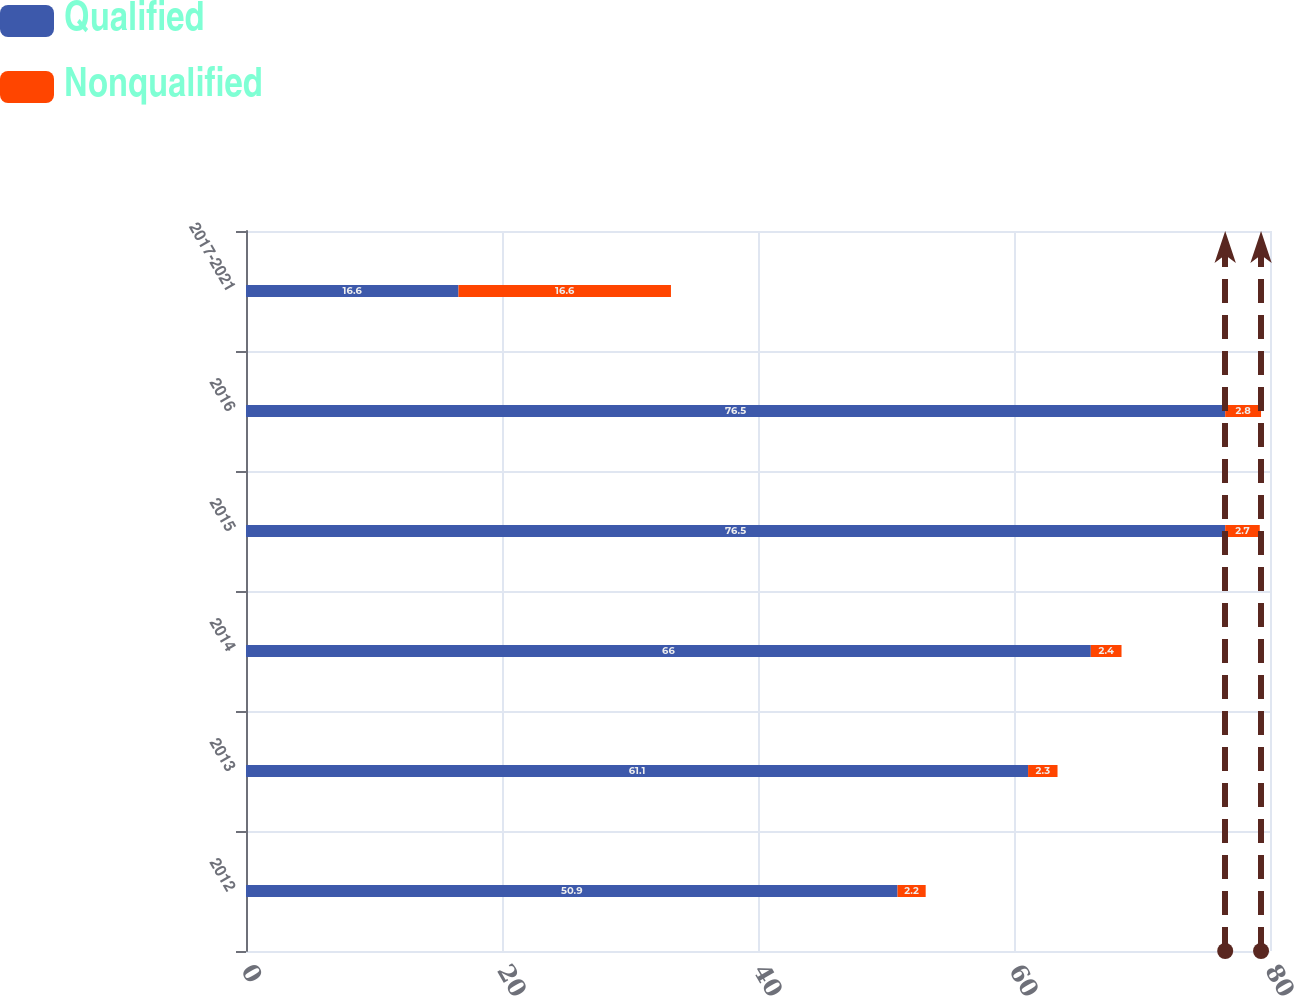Convert chart. <chart><loc_0><loc_0><loc_500><loc_500><stacked_bar_chart><ecel><fcel>2012<fcel>2013<fcel>2014<fcel>2015<fcel>2016<fcel>2017-2021<nl><fcel>Qualified<fcel>50.9<fcel>61.1<fcel>66<fcel>76.5<fcel>76.5<fcel>16.6<nl><fcel>Nonqualified<fcel>2.2<fcel>2.3<fcel>2.4<fcel>2.7<fcel>2.8<fcel>16.6<nl></chart> 